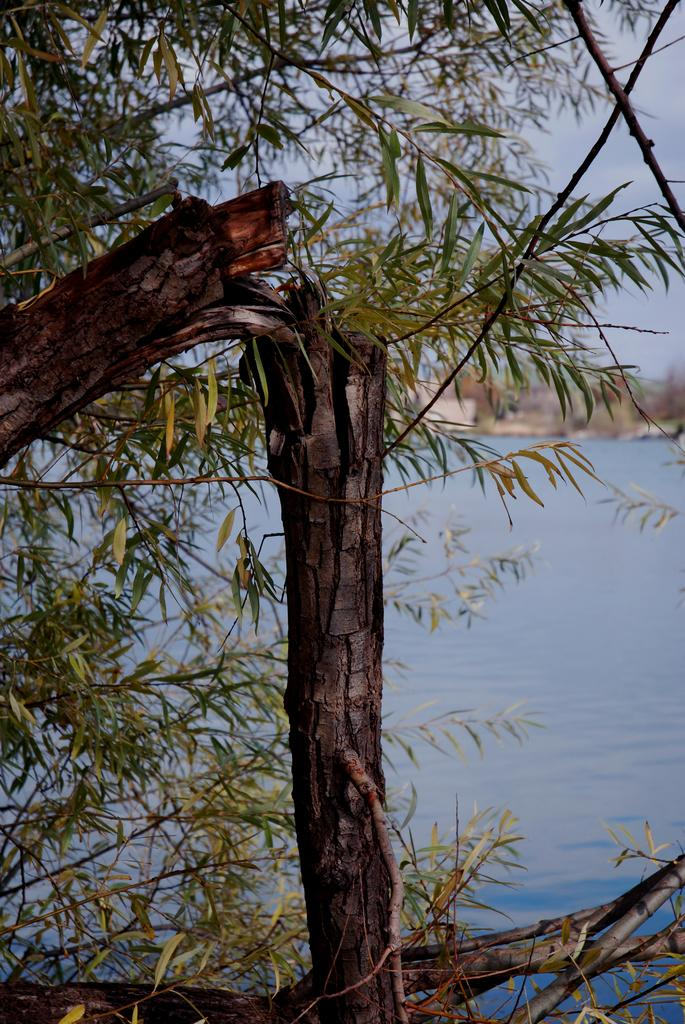What is located in the foreground of the image? There is a tree in the foreground of the image. What can be seen in the background of the image? There is a sea visible in the background of the image, and there are houses in the background as well. What type of coat is the fireman wearing in the image? There is no fireman or coat present in the image. How is the division between the sea and the houses depicted in the image? The image does not show a division between the sea and the houses; it simply shows the sea and houses in the background. 